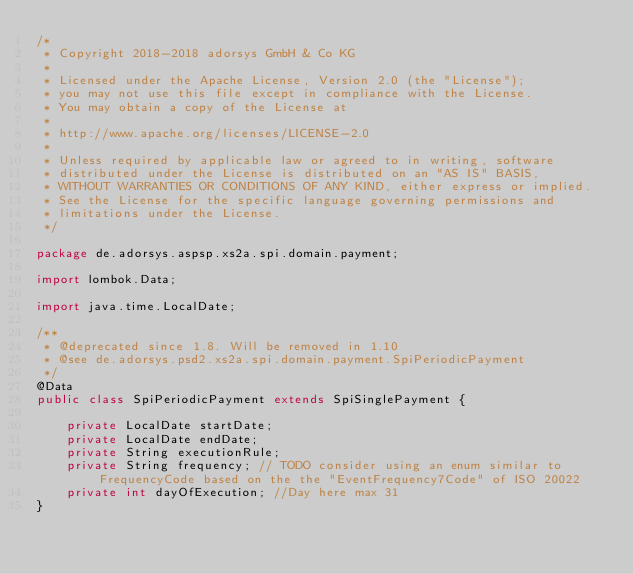Convert code to text. <code><loc_0><loc_0><loc_500><loc_500><_Java_>/*
 * Copyright 2018-2018 adorsys GmbH & Co KG
 *
 * Licensed under the Apache License, Version 2.0 (the "License");
 * you may not use this file except in compliance with the License.
 * You may obtain a copy of the License at
 *
 * http://www.apache.org/licenses/LICENSE-2.0
 *
 * Unless required by applicable law or agreed to in writing, software
 * distributed under the License is distributed on an "AS IS" BASIS,
 * WITHOUT WARRANTIES OR CONDITIONS OF ANY KIND, either express or implied.
 * See the License for the specific language governing permissions and
 * limitations under the License.
 */

package de.adorsys.aspsp.xs2a.spi.domain.payment;

import lombok.Data;

import java.time.LocalDate;

/**
 * @deprecated since 1.8. Will be removed in 1.10
 * @see de.adorsys.psd2.xs2a.spi.domain.payment.SpiPeriodicPayment
 */
@Data
public class SpiPeriodicPayment extends SpiSinglePayment {

    private LocalDate startDate;
    private LocalDate endDate;
    private String executionRule;
    private String frequency; // TODO consider using an enum similar to FrequencyCode based on the the "EventFrequency7Code" of ISO 20022
    private int dayOfExecution; //Day here max 31
}
</code> 